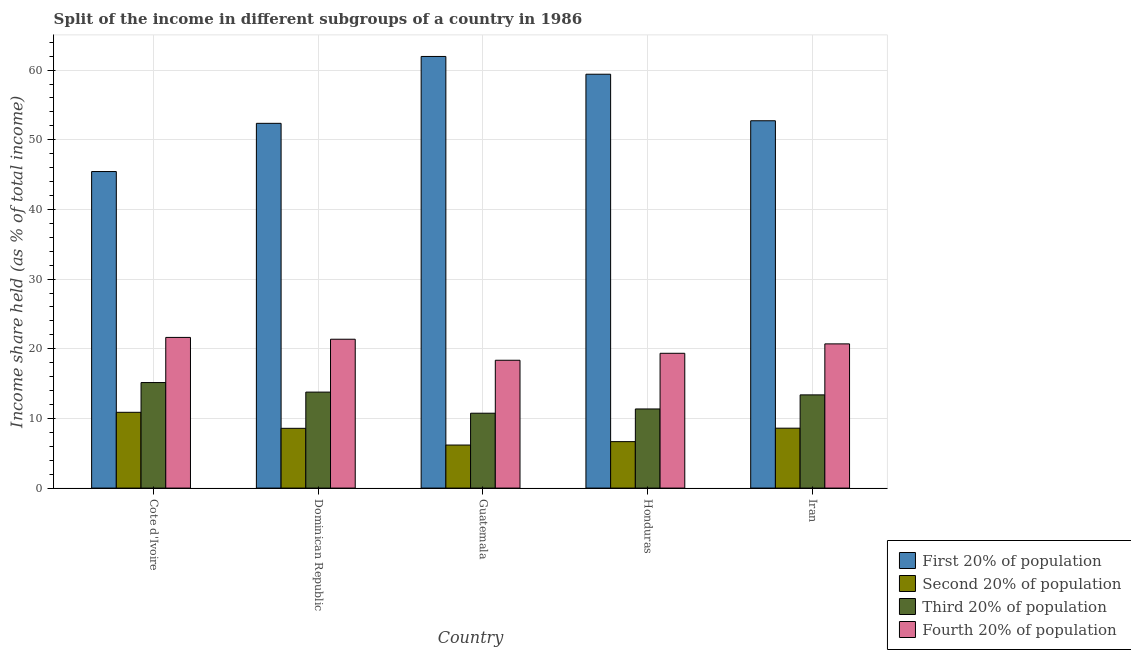What is the label of the 4th group of bars from the left?
Offer a very short reply. Honduras. In how many cases, is the number of bars for a given country not equal to the number of legend labels?
Offer a very short reply. 0. What is the share of the income held by first 20% of the population in Iran?
Offer a terse response. 52.73. Across all countries, what is the maximum share of the income held by third 20% of the population?
Make the answer very short. 15.15. Across all countries, what is the minimum share of the income held by fourth 20% of the population?
Offer a terse response. 18.35. In which country was the share of the income held by fourth 20% of the population maximum?
Your answer should be very brief. Cote d'Ivoire. In which country was the share of the income held by third 20% of the population minimum?
Make the answer very short. Guatemala. What is the total share of the income held by fourth 20% of the population in the graph?
Provide a short and direct response. 101.4. What is the difference between the share of the income held by first 20% of the population in Cote d'Ivoire and that in Honduras?
Provide a succinct answer. -13.97. What is the difference between the share of the income held by third 20% of the population in Honduras and the share of the income held by second 20% of the population in Guatemala?
Provide a short and direct response. 5.18. What is the average share of the income held by second 20% of the population per country?
Keep it short and to the point. 8.18. What is the difference between the share of the income held by second 20% of the population and share of the income held by third 20% of the population in Iran?
Provide a short and direct response. -4.78. What is the ratio of the share of the income held by first 20% of the population in Cote d'Ivoire to that in Iran?
Your response must be concise. 0.86. Is the difference between the share of the income held by third 20% of the population in Dominican Republic and Guatemala greater than the difference between the share of the income held by second 20% of the population in Dominican Republic and Guatemala?
Keep it short and to the point. Yes. What is the difference between the highest and the second highest share of the income held by fourth 20% of the population?
Ensure brevity in your answer.  0.26. Is the sum of the share of the income held by first 20% of the population in Cote d'Ivoire and Guatemala greater than the maximum share of the income held by second 20% of the population across all countries?
Offer a terse response. Yes. Is it the case that in every country, the sum of the share of the income held by third 20% of the population and share of the income held by second 20% of the population is greater than the sum of share of the income held by first 20% of the population and share of the income held by fourth 20% of the population?
Offer a terse response. Yes. What does the 3rd bar from the left in Honduras represents?
Your answer should be compact. Third 20% of population. What does the 4th bar from the right in Guatemala represents?
Offer a very short reply. First 20% of population. Is it the case that in every country, the sum of the share of the income held by first 20% of the population and share of the income held by second 20% of the population is greater than the share of the income held by third 20% of the population?
Offer a very short reply. Yes. How many bars are there?
Provide a succinct answer. 20. Are all the bars in the graph horizontal?
Give a very brief answer. No. What is the difference between two consecutive major ticks on the Y-axis?
Give a very brief answer. 10. Does the graph contain any zero values?
Your response must be concise. No. Where does the legend appear in the graph?
Your answer should be compact. Bottom right. How many legend labels are there?
Make the answer very short. 4. How are the legend labels stacked?
Offer a terse response. Vertical. What is the title of the graph?
Offer a terse response. Split of the income in different subgroups of a country in 1986. What is the label or title of the X-axis?
Offer a terse response. Country. What is the label or title of the Y-axis?
Your answer should be compact. Income share held (as % of total income). What is the Income share held (as % of total income) in First 20% of population in Cote d'Ivoire?
Your response must be concise. 45.44. What is the Income share held (as % of total income) of Second 20% of population in Cote d'Ivoire?
Your answer should be very brief. 10.88. What is the Income share held (as % of total income) in Third 20% of population in Cote d'Ivoire?
Your answer should be compact. 15.15. What is the Income share held (as % of total income) in Fourth 20% of population in Cote d'Ivoire?
Provide a short and direct response. 21.63. What is the Income share held (as % of total income) of First 20% of population in Dominican Republic?
Provide a short and direct response. 52.36. What is the Income share held (as % of total income) of Second 20% of population in Dominican Republic?
Offer a very short reply. 8.58. What is the Income share held (as % of total income) of Third 20% of population in Dominican Republic?
Your response must be concise. 13.78. What is the Income share held (as % of total income) of Fourth 20% of population in Dominican Republic?
Your answer should be compact. 21.37. What is the Income share held (as % of total income) in First 20% of population in Guatemala?
Make the answer very short. 61.96. What is the Income share held (as % of total income) in Second 20% of population in Guatemala?
Ensure brevity in your answer.  6.18. What is the Income share held (as % of total income) of Third 20% of population in Guatemala?
Ensure brevity in your answer.  10.75. What is the Income share held (as % of total income) of Fourth 20% of population in Guatemala?
Your response must be concise. 18.35. What is the Income share held (as % of total income) of First 20% of population in Honduras?
Provide a short and direct response. 59.41. What is the Income share held (as % of total income) in Second 20% of population in Honduras?
Your response must be concise. 6.67. What is the Income share held (as % of total income) in Third 20% of population in Honduras?
Ensure brevity in your answer.  11.36. What is the Income share held (as % of total income) of Fourth 20% of population in Honduras?
Give a very brief answer. 19.35. What is the Income share held (as % of total income) in First 20% of population in Iran?
Keep it short and to the point. 52.73. What is the Income share held (as % of total income) in Third 20% of population in Iran?
Keep it short and to the point. 13.38. What is the Income share held (as % of total income) in Fourth 20% of population in Iran?
Provide a succinct answer. 20.7. Across all countries, what is the maximum Income share held (as % of total income) of First 20% of population?
Your response must be concise. 61.96. Across all countries, what is the maximum Income share held (as % of total income) of Second 20% of population?
Provide a short and direct response. 10.88. Across all countries, what is the maximum Income share held (as % of total income) in Third 20% of population?
Make the answer very short. 15.15. Across all countries, what is the maximum Income share held (as % of total income) in Fourth 20% of population?
Offer a terse response. 21.63. Across all countries, what is the minimum Income share held (as % of total income) in First 20% of population?
Offer a very short reply. 45.44. Across all countries, what is the minimum Income share held (as % of total income) of Second 20% of population?
Your answer should be compact. 6.18. Across all countries, what is the minimum Income share held (as % of total income) in Third 20% of population?
Your answer should be very brief. 10.75. Across all countries, what is the minimum Income share held (as % of total income) of Fourth 20% of population?
Give a very brief answer. 18.35. What is the total Income share held (as % of total income) in First 20% of population in the graph?
Keep it short and to the point. 271.9. What is the total Income share held (as % of total income) of Second 20% of population in the graph?
Keep it short and to the point. 40.91. What is the total Income share held (as % of total income) of Third 20% of population in the graph?
Ensure brevity in your answer.  64.42. What is the total Income share held (as % of total income) in Fourth 20% of population in the graph?
Ensure brevity in your answer.  101.4. What is the difference between the Income share held (as % of total income) of First 20% of population in Cote d'Ivoire and that in Dominican Republic?
Your answer should be compact. -6.92. What is the difference between the Income share held (as % of total income) in Second 20% of population in Cote d'Ivoire and that in Dominican Republic?
Give a very brief answer. 2.3. What is the difference between the Income share held (as % of total income) of Third 20% of population in Cote d'Ivoire and that in Dominican Republic?
Provide a succinct answer. 1.37. What is the difference between the Income share held (as % of total income) in Fourth 20% of population in Cote d'Ivoire and that in Dominican Republic?
Make the answer very short. 0.26. What is the difference between the Income share held (as % of total income) of First 20% of population in Cote d'Ivoire and that in Guatemala?
Keep it short and to the point. -16.52. What is the difference between the Income share held (as % of total income) of Third 20% of population in Cote d'Ivoire and that in Guatemala?
Your answer should be very brief. 4.4. What is the difference between the Income share held (as % of total income) of Fourth 20% of population in Cote d'Ivoire and that in Guatemala?
Ensure brevity in your answer.  3.28. What is the difference between the Income share held (as % of total income) of First 20% of population in Cote d'Ivoire and that in Honduras?
Your answer should be compact. -13.97. What is the difference between the Income share held (as % of total income) of Second 20% of population in Cote d'Ivoire and that in Honduras?
Make the answer very short. 4.21. What is the difference between the Income share held (as % of total income) of Third 20% of population in Cote d'Ivoire and that in Honduras?
Give a very brief answer. 3.79. What is the difference between the Income share held (as % of total income) in Fourth 20% of population in Cote d'Ivoire and that in Honduras?
Make the answer very short. 2.28. What is the difference between the Income share held (as % of total income) of First 20% of population in Cote d'Ivoire and that in Iran?
Provide a succinct answer. -7.29. What is the difference between the Income share held (as % of total income) of Second 20% of population in Cote d'Ivoire and that in Iran?
Offer a very short reply. 2.28. What is the difference between the Income share held (as % of total income) in Third 20% of population in Cote d'Ivoire and that in Iran?
Provide a succinct answer. 1.77. What is the difference between the Income share held (as % of total income) of First 20% of population in Dominican Republic and that in Guatemala?
Make the answer very short. -9.6. What is the difference between the Income share held (as % of total income) in Second 20% of population in Dominican Republic and that in Guatemala?
Ensure brevity in your answer.  2.4. What is the difference between the Income share held (as % of total income) in Third 20% of population in Dominican Republic and that in Guatemala?
Give a very brief answer. 3.03. What is the difference between the Income share held (as % of total income) of Fourth 20% of population in Dominican Republic and that in Guatemala?
Give a very brief answer. 3.02. What is the difference between the Income share held (as % of total income) in First 20% of population in Dominican Republic and that in Honduras?
Offer a very short reply. -7.05. What is the difference between the Income share held (as % of total income) of Second 20% of population in Dominican Republic and that in Honduras?
Keep it short and to the point. 1.91. What is the difference between the Income share held (as % of total income) of Third 20% of population in Dominican Republic and that in Honduras?
Offer a very short reply. 2.42. What is the difference between the Income share held (as % of total income) of Fourth 20% of population in Dominican Republic and that in Honduras?
Ensure brevity in your answer.  2.02. What is the difference between the Income share held (as % of total income) of First 20% of population in Dominican Republic and that in Iran?
Your response must be concise. -0.37. What is the difference between the Income share held (as % of total income) in Second 20% of population in Dominican Republic and that in Iran?
Offer a terse response. -0.02. What is the difference between the Income share held (as % of total income) of Fourth 20% of population in Dominican Republic and that in Iran?
Your answer should be very brief. 0.67. What is the difference between the Income share held (as % of total income) of First 20% of population in Guatemala and that in Honduras?
Offer a very short reply. 2.55. What is the difference between the Income share held (as % of total income) of Second 20% of population in Guatemala and that in Honduras?
Make the answer very short. -0.49. What is the difference between the Income share held (as % of total income) of Third 20% of population in Guatemala and that in Honduras?
Provide a succinct answer. -0.61. What is the difference between the Income share held (as % of total income) in Fourth 20% of population in Guatemala and that in Honduras?
Offer a terse response. -1. What is the difference between the Income share held (as % of total income) in First 20% of population in Guatemala and that in Iran?
Offer a terse response. 9.23. What is the difference between the Income share held (as % of total income) of Second 20% of population in Guatemala and that in Iran?
Your response must be concise. -2.42. What is the difference between the Income share held (as % of total income) of Third 20% of population in Guatemala and that in Iran?
Your answer should be compact. -2.63. What is the difference between the Income share held (as % of total income) in Fourth 20% of population in Guatemala and that in Iran?
Offer a terse response. -2.35. What is the difference between the Income share held (as % of total income) of First 20% of population in Honduras and that in Iran?
Make the answer very short. 6.68. What is the difference between the Income share held (as % of total income) in Second 20% of population in Honduras and that in Iran?
Offer a very short reply. -1.93. What is the difference between the Income share held (as % of total income) of Third 20% of population in Honduras and that in Iran?
Give a very brief answer. -2.02. What is the difference between the Income share held (as % of total income) in Fourth 20% of population in Honduras and that in Iran?
Ensure brevity in your answer.  -1.35. What is the difference between the Income share held (as % of total income) of First 20% of population in Cote d'Ivoire and the Income share held (as % of total income) of Second 20% of population in Dominican Republic?
Offer a very short reply. 36.86. What is the difference between the Income share held (as % of total income) in First 20% of population in Cote d'Ivoire and the Income share held (as % of total income) in Third 20% of population in Dominican Republic?
Provide a short and direct response. 31.66. What is the difference between the Income share held (as % of total income) of First 20% of population in Cote d'Ivoire and the Income share held (as % of total income) of Fourth 20% of population in Dominican Republic?
Give a very brief answer. 24.07. What is the difference between the Income share held (as % of total income) of Second 20% of population in Cote d'Ivoire and the Income share held (as % of total income) of Third 20% of population in Dominican Republic?
Provide a succinct answer. -2.9. What is the difference between the Income share held (as % of total income) of Second 20% of population in Cote d'Ivoire and the Income share held (as % of total income) of Fourth 20% of population in Dominican Republic?
Your response must be concise. -10.49. What is the difference between the Income share held (as % of total income) of Third 20% of population in Cote d'Ivoire and the Income share held (as % of total income) of Fourth 20% of population in Dominican Republic?
Your answer should be very brief. -6.22. What is the difference between the Income share held (as % of total income) of First 20% of population in Cote d'Ivoire and the Income share held (as % of total income) of Second 20% of population in Guatemala?
Provide a short and direct response. 39.26. What is the difference between the Income share held (as % of total income) in First 20% of population in Cote d'Ivoire and the Income share held (as % of total income) in Third 20% of population in Guatemala?
Your answer should be very brief. 34.69. What is the difference between the Income share held (as % of total income) of First 20% of population in Cote d'Ivoire and the Income share held (as % of total income) of Fourth 20% of population in Guatemala?
Your answer should be very brief. 27.09. What is the difference between the Income share held (as % of total income) in Second 20% of population in Cote d'Ivoire and the Income share held (as % of total income) in Third 20% of population in Guatemala?
Your answer should be very brief. 0.13. What is the difference between the Income share held (as % of total income) in Second 20% of population in Cote d'Ivoire and the Income share held (as % of total income) in Fourth 20% of population in Guatemala?
Your answer should be compact. -7.47. What is the difference between the Income share held (as % of total income) of First 20% of population in Cote d'Ivoire and the Income share held (as % of total income) of Second 20% of population in Honduras?
Offer a very short reply. 38.77. What is the difference between the Income share held (as % of total income) of First 20% of population in Cote d'Ivoire and the Income share held (as % of total income) of Third 20% of population in Honduras?
Give a very brief answer. 34.08. What is the difference between the Income share held (as % of total income) in First 20% of population in Cote d'Ivoire and the Income share held (as % of total income) in Fourth 20% of population in Honduras?
Ensure brevity in your answer.  26.09. What is the difference between the Income share held (as % of total income) of Second 20% of population in Cote d'Ivoire and the Income share held (as % of total income) of Third 20% of population in Honduras?
Give a very brief answer. -0.48. What is the difference between the Income share held (as % of total income) in Second 20% of population in Cote d'Ivoire and the Income share held (as % of total income) in Fourth 20% of population in Honduras?
Keep it short and to the point. -8.47. What is the difference between the Income share held (as % of total income) in First 20% of population in Cote d'Ivoire and the Income share held (as % of total income) in Second 20% of population in Iran?
Offer a very short reply. 36.84. What is the difference between the Income share held (as % of total income) of First 20% of population in Cote d'Ivoire and the Income share held (as % of total income) of Third 20% of population in Iran?
Ensure brevity in your answer.  32.06. What is the difference between the Income share held (as % of total income) in First 20% of population in Cote d'Ivoire and the Income share held (as % of total income) in Fourth 20% of population in Iran?
Offer a very short reply. 24.74. What is the difference between the Income share held (as % of total income) of Second 20% of population in Cote d'Ivoire and the Income share held (as % of total income) of Fourth 20% of population in Iran?
Ensure brevity in your answer.  -9.82. What is the difference between the Income share held (as % of total income) in Third 20% of population in Cote d'Ivoire and the Income share held (as % of total income) in Fourth 20% of population in Iran?
Provide a succinct answer. -5.55. What is the difference between the Income share held (as % of total income) in First 20% of population in Dominican Republic and the Income share held (as % of total income) in Second 20% of population in Guatemala?
Provide a short and direct response. 46.18. What is the difference between the Income share held (as % of total income) of First 20% of population in Dominican Republic and the Income share held (as % of total income) of Third 20% of population in Guatemala?
Keep it short and to the point. 41.61. What is the difference between the Income share held (as % of total income) of First 20% of population in Dominican Republic and the Income share held (as % of total income) of Fourth 20% of population in Guatemala?
Give a very brief answer. 34.01. What is the difference between the Income share held (as % of total income) of Second 20% of population in Dominican Republic and the Income share held (as % of total income) of Third 20% of population in Guatemala?
Keep it short and to the point. -2.17. What is the difference between the Income share held (as % of total income) in Second 20% of population in Dominican Republic and the Income share held (as % of total income) in Fourth 20% of population in Guatemala?
Your answer should be very brief. -9.77. What is the difference between the Income share held (as % of total income) in Third 20% of population in Dominican Republic and the Income share held (as % of total income) in Fourth 20% of population in Guatemala?
Ensure brevity in your answer.  -4.57. What is the difference between the Income share held (as % of total income) of First 20% of population in Dominican Republic and the Income share held (as % of total income) of Second 20% of population in Honduras?
Ensure brevity in your answer.  45.69. What is the difference between the Income share held (as % of total income) of First 20% of population in Dominican Republic and the Income share held (as % of total income) of Third 20% of population in Honduras?
Give a very brief answer. 41. What is the difference between the Income share held (as % of total income) in First 20% of population in Dominican Republic and the Income share held (as % of total income) in Fourth 20% of population in Honduras?
Ensure brevity in your answer.  33.01. What is the difference between the Income share held (as % of total income) in Second 20% of population in Dominican Republic and the Income share held (as % of total income) in Third 20% of population in Honduras?
Your answer should be very brief. -2.78. What is the difference between the Income share held (as % of total income) in Second 20% of population in Dominican Republic and the Income share held (as % of total income) in Fourth 20% of population in Honduras?
Your answer should be very brief. -10.77. What is the difference between the Income share held (as % of total income) in Third 20% of population in Dominican Republic and the Income share held (as % of total income) in Fourth 20% of population in Honduras?
Give a very brief answer. -5.57. What is the difference between the Income share held (as % of total income) of First 20% of population in Dominican Republic and the Income share held (as % of total income) of Second 20% of population in Iran?
Your response must be concise. 43.76. What is the difference between the Income share held (as % of total income) of First 20% of population in Dominican Republic and the Income share held (as % of total income) of Third 20% of population in Iran?
Your answer should be very brief. 38.98. What is the difference between the Income share held (as % of total income) of First 20% of population in Dominican Republic and the Income share held (as % of total income) of Fourth 20% of population in Iran?
Make the answer very short. 31.66. What is the difference between the Income share held (as % of total income) in Second 20% of population in Dominican Republic and the Income share held (as % of total income) in Fourth 20% of population in Iran?
Your response must be concise. -12.12. What is the difference between the Income share held (as % of total income) in Third 20% of population in Dominican Republic and the Income share held (as % of total income) in Fourth 20% of population in Iran?
Keep it short and to the point. -6.92. What is the difference between the Income share held (as % of total income) in First 20% of population in Guatemala and the Income share held (as % of total income) in Second 20% of population in Honduras?
Your answer should be compact. 55.29. What is the difference between the Income share held (as % of total income) in First 20% of population in Guatemala and the Income share held (as % of total income) in Third 20% of population in Honduras?
Offer a terse response. 50.6. What is the difference between the Income share held (as % of total income) in First 20% of population in Guatemala and the Income share held (as % of total income) in Fourth 20% of population in Honduras?
Give a very brief answer. 42.61. What is the difference between the Income share held (as % of total income) in Second 20% of population in Guatemala and the Income share held (as % of total income) in Third 20% of population in Honduras?
Provide a short and direct response. -5.18. What is the difference between the Income share held (as % of total income) in Second 20% of population in Guatemala and the Income share held (as % of total income) in Fourth 20% of population in Honduras?
Keep it short and to the point. -13.17. What is the difference between the Income share held (as % of total income) of First 20% of population in Guatemala and the Income share held (as % of total income) of Second 20% of population in Iran?
Give a very brief answer. 53.36. What is the difference between the Income share held (as % of total income) of First 20% of population in Guatemala and the Income share held (as % of total income) of Third 20% of population in Iran?
Provide a short and direct response. 48.58. What is the difference between the Income share held (as % of total income) in First 20% of population in Guatemala and the Income share held (as % of total income) in Fourth 20% of population in Iran?
Your response must be concise. 41.26. What is the difference between the Income share held (as % of total income) of Second 20% of population in Guatemala and the Income share held (as % of total income) of Fourth 20% of population in Iran?
Your answer should be compact. -14.52. What is the difference between the Income share held (as % of total income) of Third 20% of population in Guatemala and the Income share held (as % of total income) of Fourth 20% of population in Iran?
Ensure brevity in your answer.  -9.95. What is the difference between the Income share held (as % of total income) in First 20% of population in Honduras and the Income share held (as % of total income) in Second 20% of population in Iran?
Your answer should be compact. 50.81. What is the difference between the Income share held (as % of total income) in First 20% of population in Honduras and the Income share held (as % of total income) in Third 20% of population in Iran?
Offer a terse response. 46.03. What is the difference between the Income share held (as % of total income) of First 20% of population in Honduras and the Income share held (as % of total income) of Fourth 20% of population in Iran?
Provide a short and direct response. 38.71. What is the difference between the Income share held (as % of total income) of Second 20% of population in Honduras and the Income share held (as % of total income) of Third 20% of population in Iran?
Ensure brevity in your answer.  -6.71. What is the difference between the Income share held (as % of total income) in Second 20% of population in Honduras and the Income share held (as % of total income) in Fourth 20% of population in Iran?
Provide a short and direct response. -14.03. What is the difference between the Income share held (as % of total income) of Third 20% of population in Honduras and the Income share held (as % of total income) of Fourth 20% of population in Iran?
Give a very brief answer. -9.34. What is the average Income share held (as % of total income) of First 20% of population per country?
Your answer should be compact. 54.38. What is the average Income share held (as % of total income) in Second 20% of population per country?
Provide a short and direct response. 8.18. What is the average Income share held (as % of total income) in Third 20% of population per country?
Your response must be concise. 12.88. What is the average Income share held (as % of total income) in Fourth 20% of population per country?
Ensure brevity in your answer.  20.28. What is the difference between the Income share held (as % of total income) in First 20% of population and Income share held (as % of total income) in Second 20% of population in Cote d'Ivoire?
Provide a succinct answer. 34.56. What is the difference between the Income share held (as % of total income) of First 20% of population and Income share held (as % of total income) of Third 20% of population in Cote d'Ivoire?
Your response must be concise. 30.29. What is the difference between the Income share held (as % of total income) in First 20% of population and Income share held (as % of total income) in Fourth 20% of population in Cote d'Ivoire?
Offer a very short reply. 23.81. What is the difference between the Income share held (as % of total income) in Second 20% of population and Income share held (as % of total income) in Third 20% of population in Cote d'Ivoire?
Your answer should be compact. -4.27. What is the difference between the Income share held (as % of total income) of Second 20% of population and Income share held (as % of total income) of Fourth 20% of population in Cote d'Ivoire?
Your answer should be compact. -10.75. What is the difference between the Income share held (as % of total income) of Third 20% of population and Income share held (as % of total income) of Fourth 20% of population in Cote d'Ivoire?
Your answer should be compact. -6.48. What is the difference between the Income share held (as % of total income) in First 20% of population and Income share held (as % of total income) in Second 20% of population in Dominican Republic?
Your answer should be compact. 43.78. What is the difference between the Income share held (as % of total income) of First 20% of population and Income share held (as % of total income) of Third 20% of population in Dominican Republic?
Your response must be concise. 38.58. What is the difference between the Income share held (as % of total income) in First 20% of population and Income share held (as % of total income) in Fourth 20% of population in Dominican Republic?
Offer a very short reply. 30.99. What is the difference between the Income share held (as % of total income) in Second 20% of population and Income share held (as % of total income) in Fourth 20% of population in Dominican Republic?
Make the answer very short. -12.79. What is the difference between the Income share held (as % of total income) in Third 20% of population and Income share held (as % of total income) in Fourth 20% of population in Dominican Republic?
Keep it short and to the point. -7.59. What is the difference between the Income share held (as % of total income) in First 20% of population and Income share held (as % of total income) in Second 20% of population in Guatemala?
Your answer should be compact. 55.78. What is the difference between the Income share held (as % of total income) in First 20% of population and Income share held (as % of total income) in Third 20% of population in Guatemala?
Your response must be concise. 51.21. What is the difference between the Income share held (as % of total income) in First 20% of population and Income share held (as % of total income) in Fourth 20% of population in Guatemala?
Offer a terse response. 43.61. What is the difference between the Income share held (as % of total income) of Second 20% of population and Income share held (as % of total income) of Third 20% of population in Guatemala?
Your answer should be very brief. -4.57. What is the difference between the Income share held (as % of total income) of Second 20% of population and Income share held (as % of total income) of Fourth 20% of population in Guatemala?
Keep it short and to the point. -12.17. What is the difference between the Income share held (as % of total income) of First 20% of population and Income share held (as % of total income) of Second 20% of population in Honduras?
Provide a succinct answer. 52.74. What is the difference between the Income share held (as % of total income) in First 20% of population and Income share held (as % of total income) in Third 20% of population in Honduras?
Offer a very short reply. 48.05. What is the difference between the Income share held (as % of total income) in First 20% of population and Income share held (as % of total income) in Fourth 20% of population in Honduras?
Provide a succinct answer. 40.06. What is the difference between the Income share held (as % of total income) in Second 20% of population and Income share held (as % of total income) in Third 20% of population in Honduras?
Make the answer very short. -4.69. What is the difference between the Income share held (as % of total income) of Second 20% of population and Income share held (as % of total income) of Fourth 20% of population in Honduras?
Provide a succinct answer. -12.68. What is the difference between the Income share held (as % of total income) in Third 20% of population and Income share held (as % of total income) in Fourth 20% of population in Honduras?
Your answer should be compact. -7.99. What is the difference between the Income share held (as % of total income) of First 20% of population and Income share held (as % of total income) of Second 20% of population in Iran?
Your answer should be compact. 44.13. What is the difference between the Income share held (as % of total income) in First 20% of population and Income share held (as % of total income) in Third 20% of population in Iran?
Make the answer very short. 39.35. What is the difference between the Income share held (as % of total income) in First 20% of population and Income share held (as % of total income) in Fourth 20% of population in Iran?
Provide a succinct answer. 32.03. What is the difference between the Income share held (as % of total income) of Second 20% of population and Income share held (as % of total income) of Third 20% of population in Iran?
Keep it short and to the point. -4.78. What is the difference between the Income share held (as % of total income) of Second 20% of population and Income share held (as % of total income) of Fourth 20% of population in Iran?
Your answer should be compact. -12.1. What is the difference between the Income share held (as % of total income) in Third 20% of population and Income share held (as % of total income) in Fourth 20% of population in Iran?
Your response must be concise. -7.32. What is the ratio of the Income share held (as % of total income) in First 20% of population in Cote d'Ivoire to that in Dominican Republic?
Make the answer very short. 0.87. What is the ratio of the Income share held (as % of total income) of Second 20% of population in Cote d'Ivoire to that in Dominican Republic?
Ensure brevity in your answer.  1.27. What is the ratio of the Income share held (as % of total income) in Third 20% of population in Cote d'Ivoire to that in Dominican Republic?
Keep it short and to the point. 1.1. What is the ratio of the Income share held (as % of total income) in Fourth 20% of population in Cote d'Ivoire to that in Dominican Republic?
Your response must be concise. 1.01. What is the ratio of the Income share held (as % of total income) of First 20% of population in Cote d'Ivoire to that in Guatemala?
Give a very brief answer. 0.73. What is the ratio of the Income share held (as % of total income) in Second 20% of population in Cote d'Ivoire to that in Guatemala?
Provide a short and direct response. 1.76. What is the ratio of the Income share held (as % of total income) in Third 20% of population in Cote d'Ivoire to that in Guatemala?
Provide a succinct answer. 1.41. What is the ratio of the Income share held (as % of total income) in Fourth 20% of population in Cote d'Ivoire to that in Guatemala?
Offer a terse response. 1.18. What is the ratio of the Income share held (as % of total income) in First 20% of population in Cote d'Ivoire to that in Honduras?
Give a very brief answer. 0.76. What is the ratio of the Income share held (as % of total income) in Second 20% of population in Cote d'Ivoire to that in Honduras?
Provide a short and direct response. 1.63. What is the ratio of the Income share held (as % of total income) in Third 20% of population in Cote d'Ivoire to that in Honduras?
Offer a very short reply. 1.33. What is the ratio of the Income share held (as % of total income) of Fourth 20% of population in Cote d'Ivoire to that in Honduras?
Offer a terse response. 1.12. What is the ratio of the Income share held (as % of total income) in First 20% of population in Cote d'Ivoire to that in Iran?
Make the answer very short. 0.86. What is the ratio of the Income share held (as % of total income) of Second 20% of population in Cote d'Ivoire to that in Iran?
Ensure brevity in your answer.  1.27. What is the ratio of the Income share held (as % of total income) of Third 20% of population in Cote d'Ivoire to that in Iran?
Your answer should be compact. 1.13. What is the ratio of the Income share held (as % of total income) of Fourth 20% of population in Cote d'Ivoire to that in Iran?
Make the answer very short. 1.04. What is the ratio of the Income share held (as % of total income) in First 20% of population in Dominican Republic to that in Guatemala?
Offer a terse response. 0.85. What is the ratio of the Income share held (as % of total income) in Second 20% of population in Dominican Republic to that in Guatemala?
Give a very brief answer. 1.39. What is the ratio of the Income share held (as % of total income) in Third 20% of population in Dominican Republic to that in Guatemala?
Keep it short and to the point. 1.28. What is the ratio of the Income share held (as % of total income) in Fourth 20% of population in Dominican Republic to that in Guatemala?
Make the answer very short. 1.16. What is the ratio of the Income share held (as % of total income) of First 20% of population in Dominican Republic to that in Honduras?
Your answer should be very brief. 0.88. What is the ratio of the Income share held (as % of total income) in Second 20% of population in Dominican Republic to that in Honduras?
Give a very brief answer. 1.29. What is the ratio of the Income share held (as % of total income) of Third 20% of population in Dominican Republic to that in Honduras?
Provide a succinct answer. 1.21. What is the ratio of the Income share held (as % of total income) of Fourth 20% of population in Dominican Republic to that in Honduras?
Provide a succinct answer. 1.1. What is the ratio of the Income share held (as % of total income) of Third 20% of population in Dominican Republic to that in Iran?
Keep it short and to the point. 1.03. What is the ratio of the Income share held (as % of total income) of Fourth 20% of population in Dominican Republic to that in Iran?
Offer a very short reply. 1.03. What is the ratio of the Income share held (as % of total income) of First 20% of population in Guatemala to that in Honduras?
Give a very brief answer. 1.04. What is the ratio of the Income share held (as % of total income) in Second 20% of population in Guatemala to that in Honduras?
Ensure brevity in your answer.  0.93. What is the ratio of the Income share held (as % of total income) of Third 20% of population in Guatemala to that in Honduras?
Make the answer very short. 0.95. What is the ratio of the Income share held (as % of total income) of Fourth 20% of population in Guatemala to that in Honduras?
Keep it short and to the point. 0.95. What is the ratio of the Income share held (as % of total income) of First 20% of population in Guatemala to that in Iran?
Make the answer very short. 1.18. What is the ratio of the Income share held (as % of total income) of Second 20% of population in Guatemala to that in Iran?
Keep it short and to the point. 0.72. What is the ratio of the Income share held (as % of total income) in Third 20% of population in Guatemala to that in Iran?
Ensure brevity in your answer.  0.8. What is the ratio of the Income share held (as % of total income) of Fourth 20% of population in Guatemala to that in Iran?
Ensure brevity in your answer.  0.89. What is the ratio of the Income share held (as % of total income) in First 20% of population in Honduras to that in Iran?
Make the answer very short. 1.13. What is the ratio of the Income share held (as % of total income) of Second 20% of population in Honduras to that in Iran?
Give a very brief answer. 0.78. What is the ratio of the Income share held (as % of total income) in Third 20% of population in Honduras to that in Iran?
Provide a short and direct response. 0.85. What is the ratio of the Income share held (as % of total income) in Fourth 20% of population in Honduras to that in Iran?
Your answer should be very brief. 0.93. What is the difference between the highest and the second highest Income share held (as % of total income) in First 20% of population?
Your answer should be compact. 2.55. What is the difference between the highest and the second highest Income share held (as % of total income) in Second 20% of population?
Keep it short and to the point. 2.28. What is the difference between the highest and the second highest Income share held (as % of total income) in Third 20% of population?
Offer a very short reply. 1.37. What is the difference between the highest and the second highest Income share held (as % of total income) of Fourth 20% of population?
Make the answer very short. 0.26. What is the difference between the highest and the lowest Income share held (as % of total income) of First 20% of population?
Make the answer very short. 16.52. What is the difference between the highest and the lowest Income share held (as % of total income) in Second 20% of population?
Give a very brief answer. 4.7. What is the difference between the highest and the lowest Income share held (as % of total income) of Third 20% of population?
Your response must be concise. 4.4. What is the difference between the highest and the lowest Income share held (as % of total income) of Fourth 20% of population?
Provide a short and direct response. 3.28. 